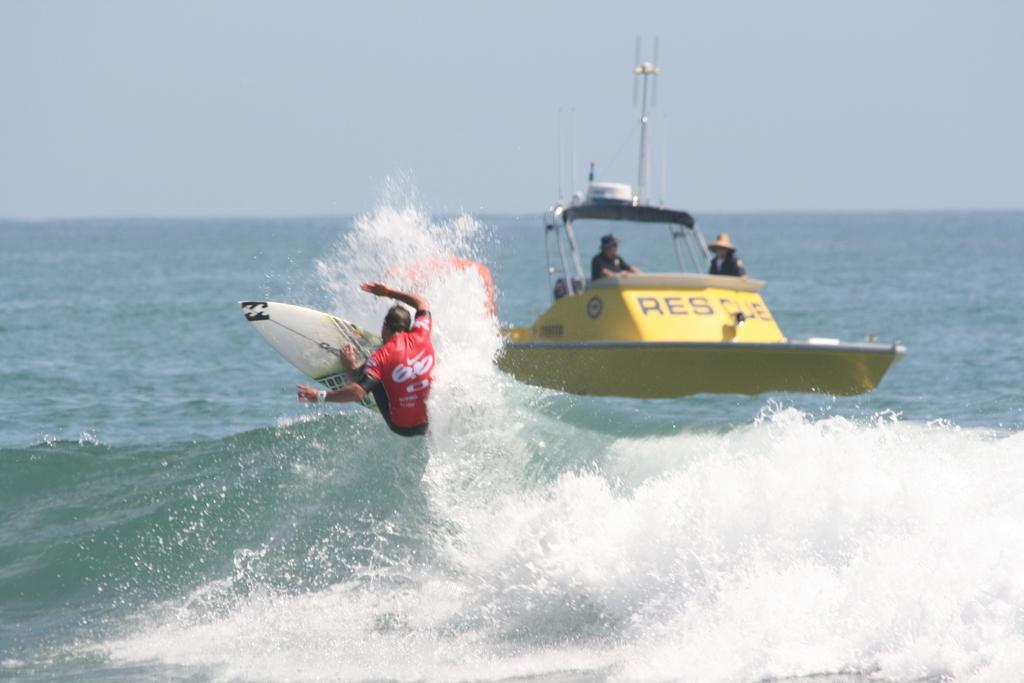What department is the yellow boat part of?
Keep it short and to the point. Rescue. What number is on the guy in red?
Keep it short and to the point. 60. 